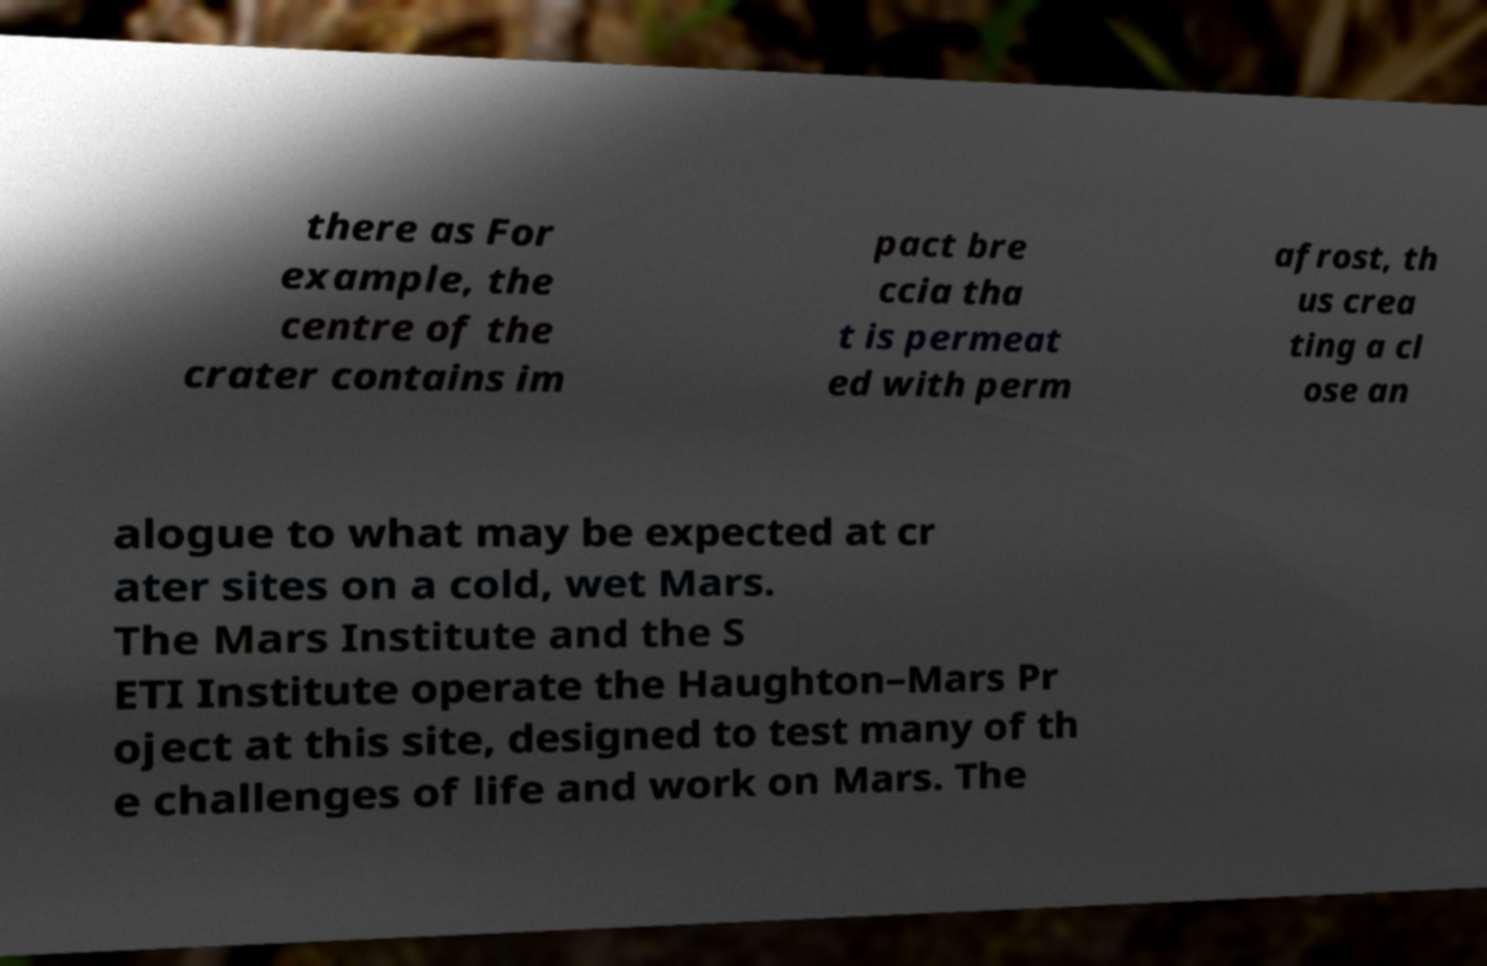Can you read and provide the text displayed in the image?This photo seems to have some interesting text. Can you extract and type it out for me? there as For example, the centre of the crater contains im pact bre ccia tha t is permeat ed with perm afrost, th us crea ting a cl ose an alogue to what may be expected at cr ater sites on a cold, wet Mars. The Mars Institute and the S ETI Institute operate the Haughton–Mars Pr oject at this site, designed to test many of th e challenges of life and work on Mars. The 